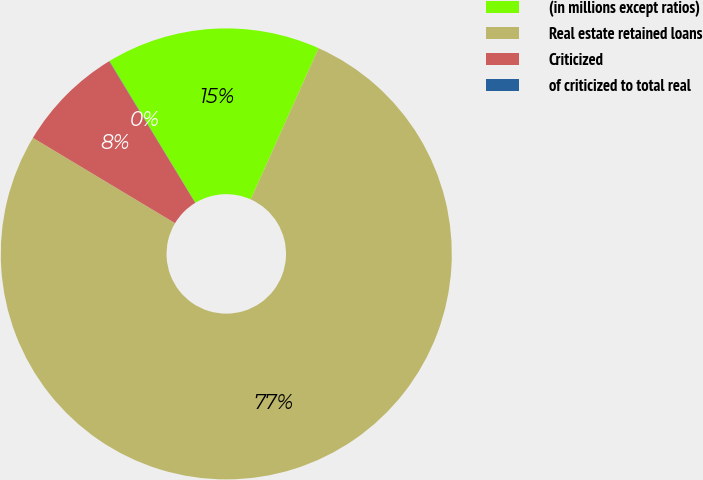<chart> <loc_0><loc_0><loc_500><loc_500><pie_chart><fcel>(in millions except ratios)<fcel>Real estate retained loans<fcel>Criticized<fcel>of criticized to total real<nl><fcel>15.39%<fcel>76.89%<fcel>7.7%<fcel>0.02%<nl></chart> 